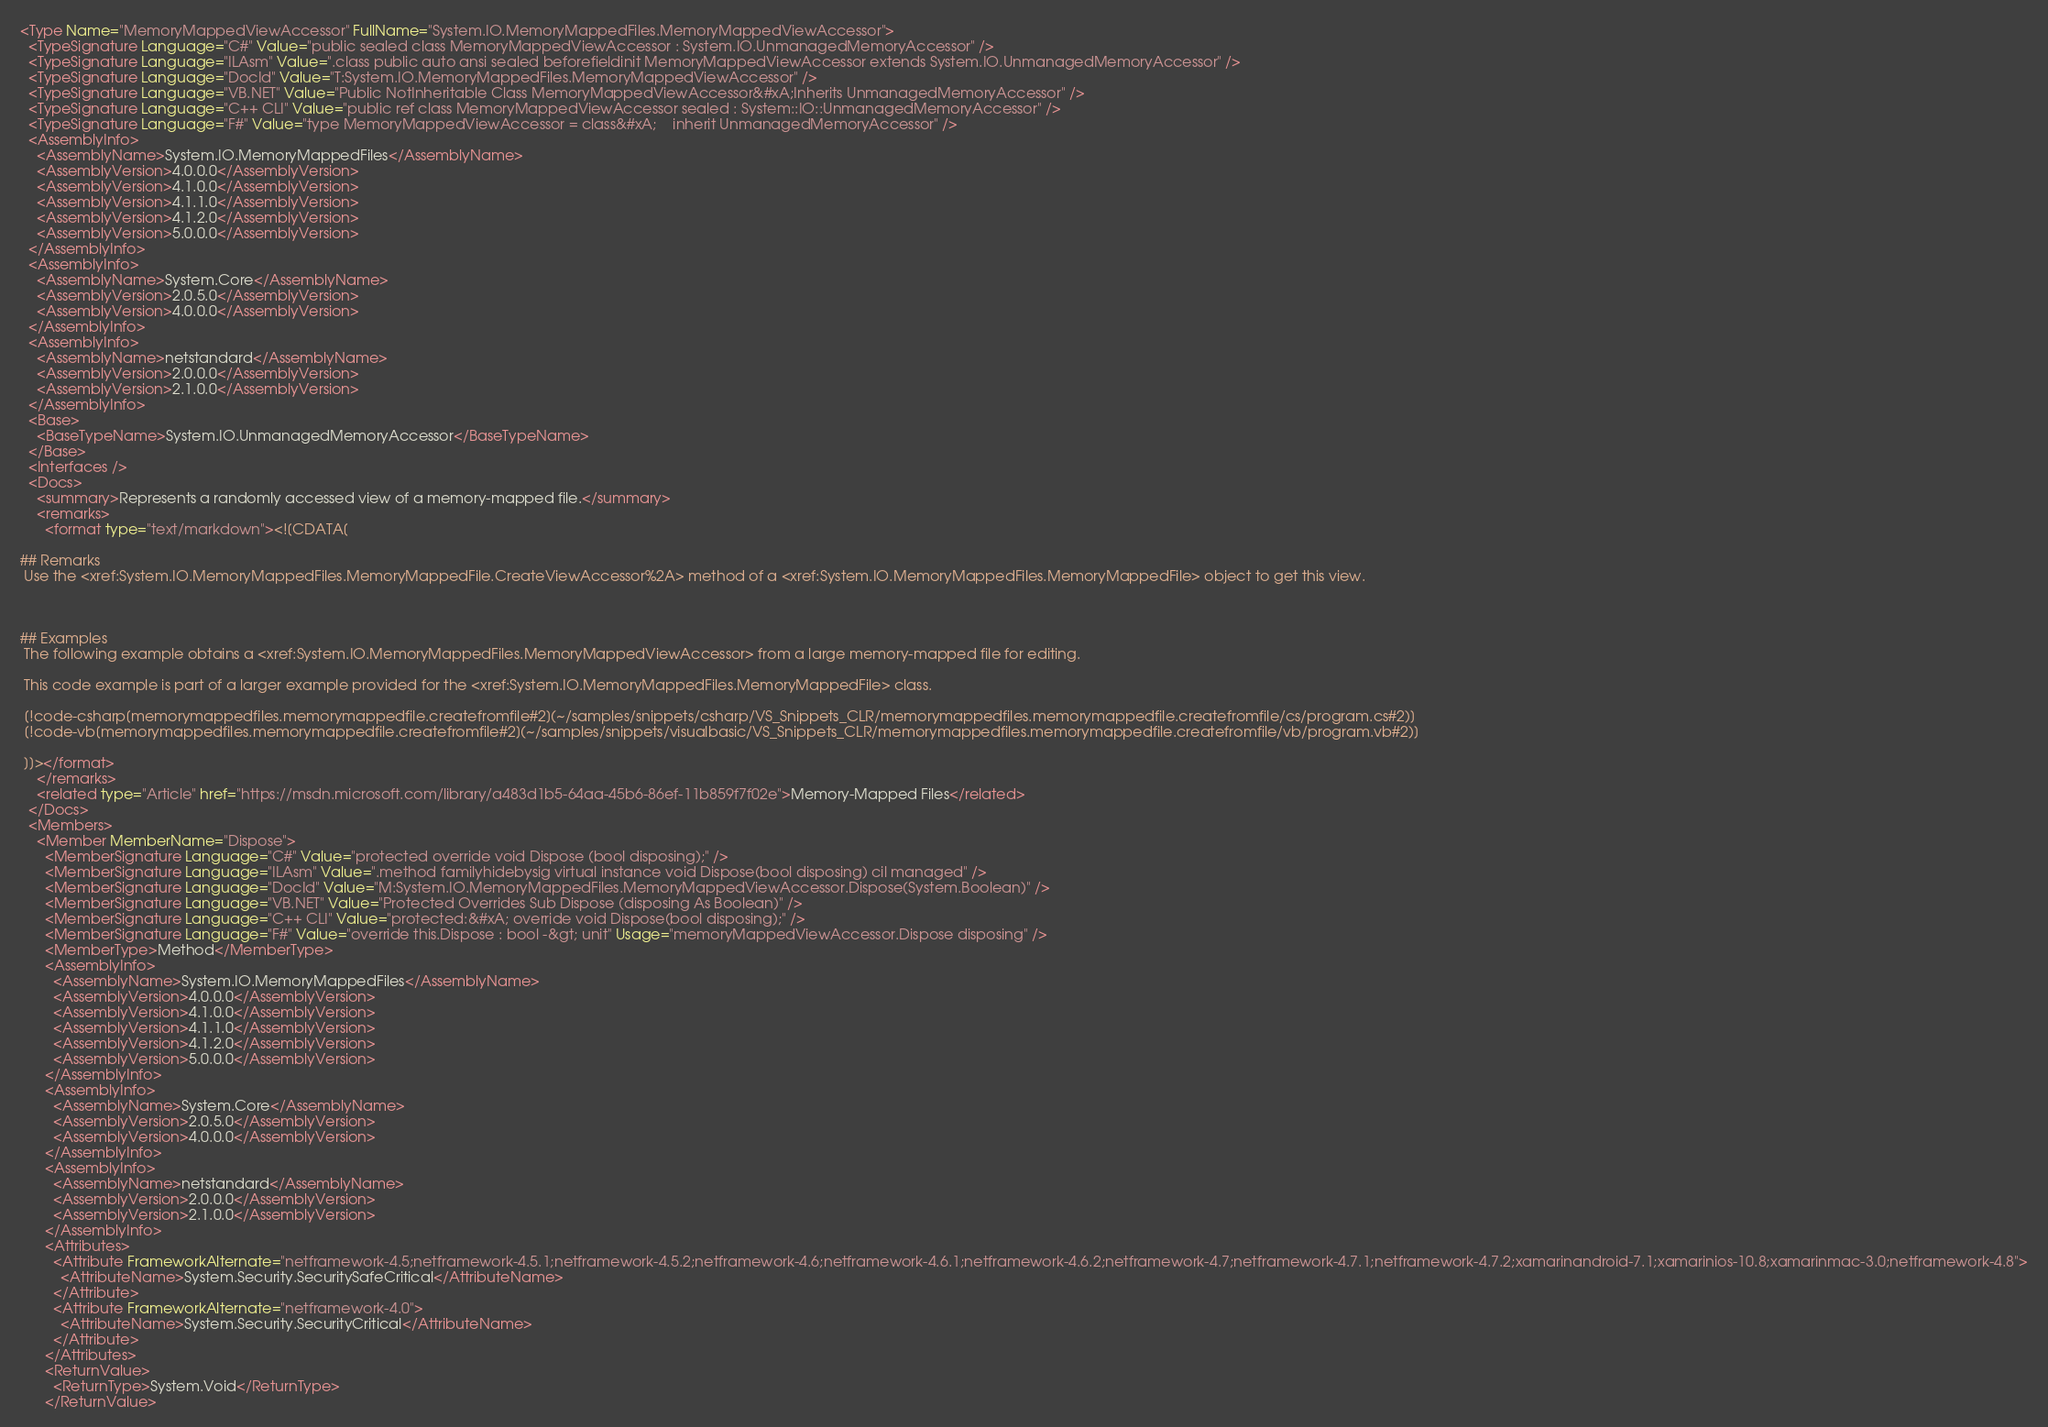<code> <loc_0><loc_0><loc_500><loc_500><_XML_><Type Name="MemoryMappedViewAccessor" FullName="System.IO.MemoryMappedFiles.MemoryMappedViewAccessor">
  <TypeSignature Language="C#" Value="public sealed class MemoryMappedViewAccessor : System.IO.UnmanagedMemoryAccessor" />
  <TypeSignature Language="ILAsm" Value=".class public auto ansi sealed beforefieldinit MemoryMappedViewAccessor extends System.IO.UnmanagedMemoryAccessor" />
  <TypeSignature Language="DocId" Value="T:System.IO.MemoryMappedFiles.MemoryMappedViewAccessor" />
  <TypeSignature Language="VB.NET" Value="Public NotInheritable Class MemoryMappedViewAccessor&#xA;Inherits UnmanagedMemoryAccessor" />
  <TypeSignature Language="C++ CLI" Value="public ref class MemoryMappedViewAccessor sealed : System::IO::UnmanagedMemoryAccessor" />
  <TypeSignature Language="F#" Value="type MemoryMappedViewAccessor = class&#xA;    inherit UnmanagedMemoryAccessor" />
  <AssemblyInfo>
    <AssemblyName>System.IO.MemoryMappedFiles</AssemblyName>
    <AssemblyVersion>4.0.0.0</AssemblyVersion>
    <AssemblyVersion>4.1.0.0</AssemblyVersion>
    <AssemblyVersion>4.1.1.0</AssemblyVersion>
    <AssemblyVersion>4.1.2.0</AssemblyVersion>
    <AssemblyVersion>5.0.0.0</AssemblyVersion>
  </AssemblyInfo>
  <AssemblyInfo>
    <AssemblyName>System.Core</AssemblyName>
    <AssemblyVersion>2.0.5.0</AssemblyVersion>
    <AssemblyVersion>4.0.0.0</AssemblyVersion>
  </AssemblyInfo>
  <AssemblyInfo>
    <AssemblyName>netstandard</AssemblyName>
    <AssemblyVersion>2.0.0.0</AssemblyVersion>
    <AssemblyVersion>2.1.0.0</AssemblyVersion>
  </AssemblyInfo>
  <Base>
    <BaseTypeName>System.IO.UnmanagedMemoryAccessor</BaseTypeName>
  </Base>
  <Interfaces />
  <Docs>
    <summary>Represents a randomly accessed view of a memory-mapped file.</summary>
    <remarks>
      <format type="text/markdown"><![CDATA[  
  
## Remarks  
 Use the <xref:System.IO.MemoryMappedFiles.MemoryMappedFile.CreateViewAccessor%2A> method of a <xref:System.IO.MemoryMappedFiles.MemoryMappedFile> object to get this view.  
  
   
  
## Examples  
 The following example obtains a <xref:System.IO.MemoryMappedFiles.MemoryMappedViewAccessor> from a large memory-mapped file for editing.  
  
 This code example is part of a larger example provided for the <xref:System.IO.MemoryMappedFiles.MemoryMappedFile> class.  
  
 [!code-csharp[memorymappedfiles.memorymappedfile.createfromfile#2](~/samples/snippets/csharp/VS_Snippets_CLR/memorymappedfiles.memorymappedfile.createfromfile/cs/program.cs#2)]
 [!code-vb[memorymappedfiles.memorymappedfile.createfromfile#2](~/samples/snippets/visualbasic/VS_Snippets_CLR/memorymappedfiles.memorymappedfile.createfromfile/vb/program.vb#2)]  
  
 ]]></format>
    </remarks>
    <related type="Article" href="https://msdn.microsoft.com/library/a483d1b5-64aa-45b6-86ef-11b859f7f02e">Memory-Mapped Files</related>
  </Docs>
  <Members>
    <Member MemberName="Dispose">
      <MemberSignature Language="C#" Value="protected override void Dispose (bool disposing);" />
      <MemberSignature Language="ILAsm" Value=".method familyhidebysig virtual instance void Dispose(bool disposing) cil managed" />
      <MemberSignature Language="DocId" Value="M:System.IO.MemoryMappedFiles.MemoryMappedViewAccessor.Dispose(System.Boolean)" />
      <MemberSignature Language="VB.NET" Value="Protected Overrides Sub Dispose (disposing As Boolean)" />
      <MemberSignature Language="C++ CLI" Value="protected:&#xA; override void Dispose(bool disposing);" />
      <MemberSignature Language="F#" Value="override this.Dispose : bool -&gt; unit" Usage="memoryMappedViewAccessor.Dispose disposing" />
      <MemberType>Method</MemberType>
      <AssemblyInfo>
        <AssemblyName>System.IO.MemoryMappedFiles</AssemblyName>
        <AssemblyVersion>4.0.0.0</AssemblyVersion>
        <AssemblyVersion>4.1.0.0</AssemblyVersion>
        <AssemblyVersion>4.1.1.0</AssemblyVersion>
        <AssemblyVersion>4.1.2.0</AssemblyVersion>
        <AssemblyVersion>5.0.0.0</AssemblyVersion>
      </AssemblyInfo>
      <AssemblyInfo>
        <AssemblyName>System.Core</AssemblyName>
        <AssemblyVersion>2.0.5.0</AssemblyVersion>
        <AssemblyVersion>4.0.0.0</AssemblyVersion>
      </AssemblyInfo>
      <AssemblyInfo>
        <AssemblyName>netstandard</AssemblyName>
        <AssemblyVersion>2.0.0.0</AssemblyVersion>
        <AssemblyVersion>2.1.0.0</AssemblyVersion>
      </AssemblyInfo>
      <Attributes>
        <Attribute FrameworkAlternate="netframework-4.5;netframework-4.5.1;netframework-4.5.2;netframework-4.6;netframework-4.6.1;netframework-4.6.2;netframework-4.7;netframework-4.7.1;netframework-4.7.2;xamarinandroid-7.1;xamarinios-10.8;xamarinmac-3.0;netframework-4.8">
          <AttributeName>System.Security.SecuritySafeCritical</AttributeName>
        </Attribute>
        <Attribute FrameworkAlternate="netframework-4.0">
          <AttributeName>System.Security.SecurityCritical</AttributeName>
        </Attribute>
      </Attributes>
      <ReturnValue>
        <ReturnType>System.Void</ReturnType>
      </ReturnValue></code> 